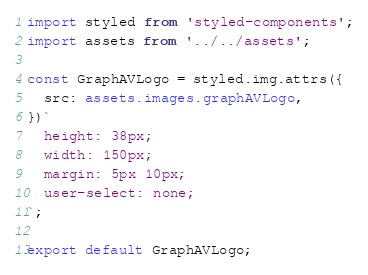<code> <loc_0><loc_0><loc_500><loc_500><_TypeScript_>import styled from 'styled-components';
import assets from '../../assets';

const GraphAVLogo = styled.img.attrs({
  src: assets.images.graphAVLogo,
})`
  height: 38px;
  width: 150px;
  margin: 5px 10px;
  user-select: none;
`;

export default GraphAVLogo;
</code> 